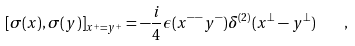<formula> <loc_0><loc_0><loc_500><loc_500>[ \sigma ( x ) , \sigma ( y ) ] _ { x ^ { + } = y ^ { + } } = - \frac { i } { 4 } \epsilon ( x ^ { - - } y ^ { - } ) \delta ^ { ( 2 ) } ( x ^ { \perp } - y ^ { \perp } ) \quad ,</formula> 